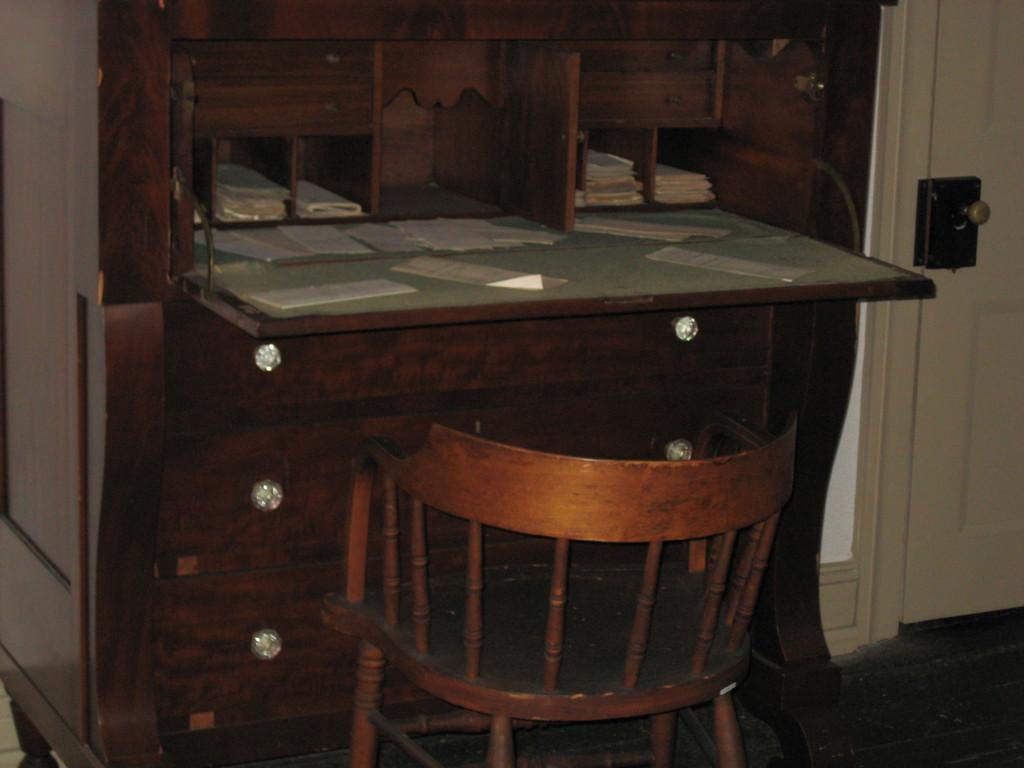In one or two sentences, can you explain what this image depicts? In this image I can see a wooden table with drawers and racks. Also there are papers and there is a door. 